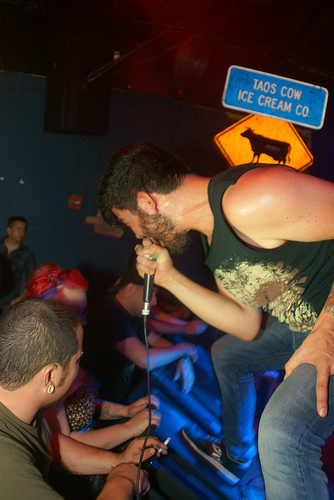<image>
Is the singer in front of the cow? Yes. The singer is positioned in front of the cow, appearing closer to the camera viewpoint. Where is the sign in relation to the above? Is it above the above? No. The sign is not positioned above the above. The vertical arrangement shows a different relationship. 